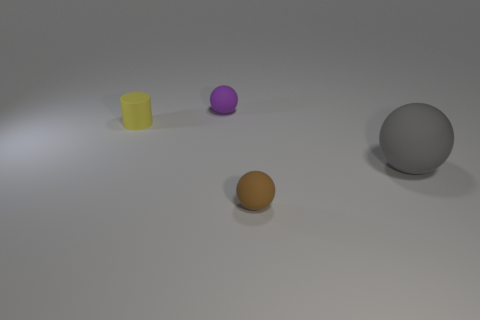What material is the tiny sphere right of the object behind the yellow thing made of?
Your answer should be compact. Rubber. There is a sphere that is behind the large gray rubber sphere; how big is it?
Your response must be concise. Small. What number of yellow objects are matte cylinders or metal cubes?
Your response must be concise. 1. Is there anything else that has the same material as the tiny brown object?
Keep it short and to the point. Yes. There is a big gray thing that is the same shape as the tiny brown rubber thing; what material is it?
Provide a succinct answer. Rubber. Is the number of brown spheres that are behind the tiny yellow rubber cylinder the same as the number of yellow matte things?
Offer a terse response. No. What is the size of the rubber sphere that is to the left of the big rubber thing and in front of the small cylinder?
Offer a very short reply. Small. Is there anything else that has the same color as the cylinder?
Keep it short and to the point. No. There is a ball on the left side of the tiny ball in front of the big gray matte object; what size is it?
Your answer should be very brief. Small. There is a ball that is both behind the small brown thing and left of the big gray matte thing; what color is it?
Your response must be concise. Purple. 